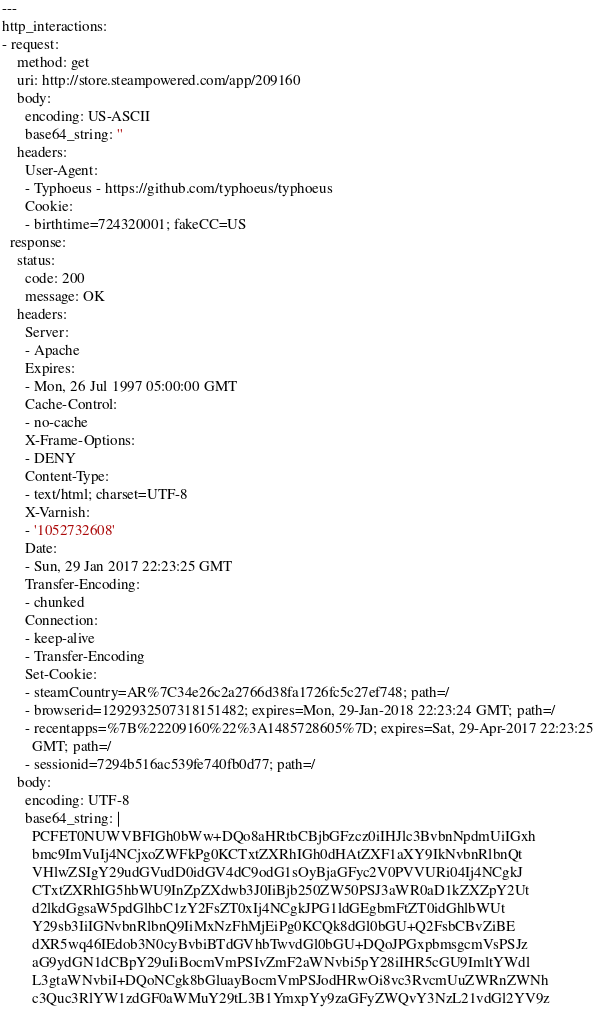<code> <loc_0><loc_0><loc_500><loc_500><_YAML_>---
http_interactions:
- request:
    method: get
    uri: http://store.steampowered.com/app/209160
    body:
      encoding: US-ASCII
      base64_string: ''
    headers:
      User-Agent:
      - Typhoeus - https://github.com/typhoeus/typhoeus
      Cookie:
      - birthtime=724320001; fakeCC=US
  response:
    status:
      code: 200
      message: OK
    headers:
      Server:
      - Apache
      Expires:
      - Mon, 26 Jul 1997 05:00:00 GMT
      Cache-Control:
      - no-cache
      X-Frame-Options:
      - DENY
      Content-Type:
      - text/html; charset=UTF-8
      X-Varnish:
      - '1052732608'
      Date:
      - Sun, 29 Jan 2017 22:23:25 GMT
      Transfer-Encoding:
      - chunked
      Connection:
      - keep-alive
      - Transfer-Encoding
      Set-Cookie:
      - steamCountry=AR%7C34e26c2a2766d38fa1726fc5c27ef748; path=/
      - browserid=1292932507318151482; expires=Mon, 29-Jan-2018 22:23:24 GMT; path=/
      - recentapps=%7B%22209160%22%3A1485728605%7D; expires=Sat, 29-Apr-2017 22:23:25
        GMT; path=/
      - sessionid=7294b516ac539fe740fb0d77; path=/
    body:
      encoding: UTF-8
      base64_string: |
        PCFET0NUWVBFIGh0bWw+DQo8aHRtbCBjbGFzcz0iIHJlc3BvbnNpdmUiIGxh
        bmc9ImVuIj4NCjxoZWFkPg0KCTxtZXRhIGh0dHAtZXF1aXY9IkNvbnRlbnQt
        VHlwZSIgY29udGVudD0idGV4dC9odG1sOyBjaGFyc2V0PVVURi04Ij4NCgkJ
        CTxtZXRhIG5hbWU9InZpZXdwb3J0IiBjb250ZW50PSJ3aWR0aD1kZXZpY2Ut
        d2lkdGgsaW5pdGlhbC1zY2FsZT0xIj4NCgkJPG1ldGEgbmFtZT0idGhlbWUt
        Y29sb3IiIGNvbnRlbnQ9IiMxNzFhMjEiPg0KCQk8dGl0bGU+Q2FsbCBvZiBE
        dXR5wq46IEdob3N0cyBvbiBTdGVhbTwvdGl0bGU+DQoJPGxpbmsgcmVsPSJz
        aG9ydGN1dCBpY29uIiBocmVmPSIvZmF2aWNvbi5pY28iIHR5cGU9ImltYWdl
        L3gtaWNvbiI+DQoNCgk8bGluayBocmVmPSJodHRwOi8vc3RvcmUuZWRnZWNh
        c3Quc3RlYW1zdGF0aWMuY29tL3B1YmxpYy9zaGFyZWQvY3NzL21vdGl2YV9z</code> 